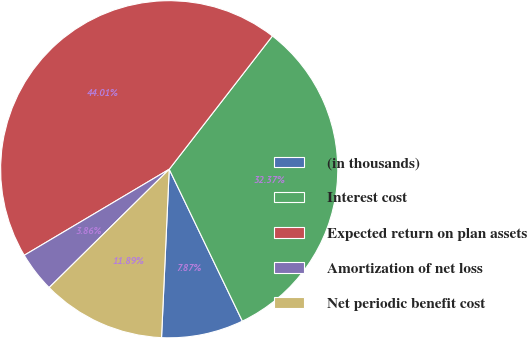Convert chart to OTSL. <chart><loc_0><loc_0><loc_500><loc_500><pie_chart><fcel>(in thousands)<fcel>Interest cost<fcel>Expected return on plan assets<fcel>Amortization of net loss<fcel>Net periodic benefit cost<nl><fcel>7.87%<fcel>32.37%<fcel>44.01%<fcel>3.86%<fcel>11.89%<nl></chart> 